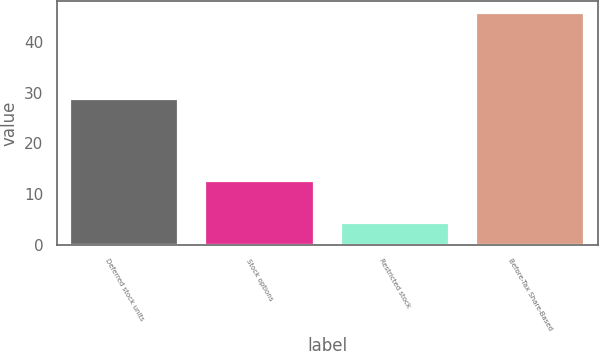Convert chart. <chart><loc_0><loc_0><loc_500><loc_500><bar_chart><fcel>Deferred stock units<fcel>Stock options<fcel>Restricted stock<fcel>Before-Tax Share-Based<nl><fcel>28.8<fcel>12.6<fcel>4.3<fcel>45.7<nl></chart> 